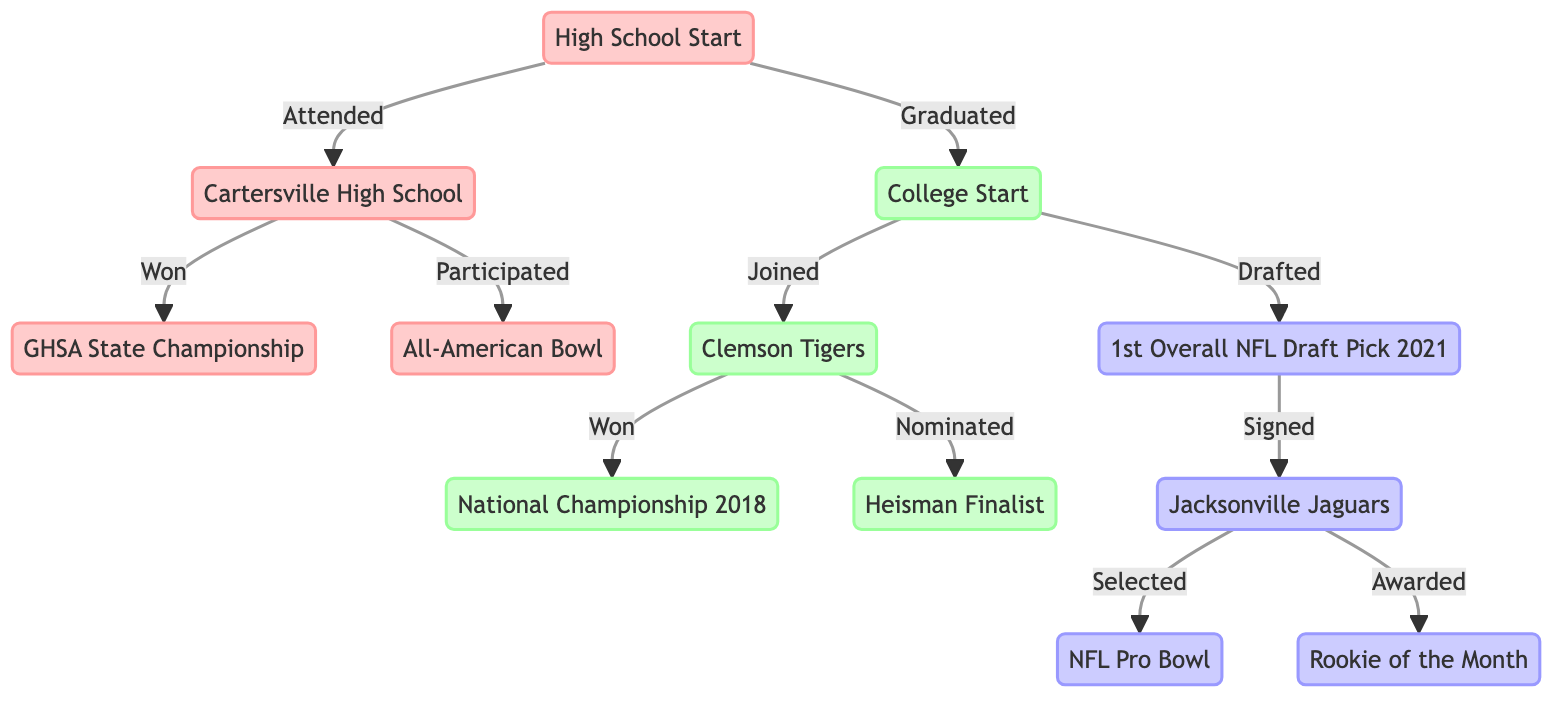What high school did Trevor Lawrence attend? The diagram shows that Trevor Lawrence attended "Cartersville High School" under the "High School" group. This is connected to the node labeled "High School Start" with the relationship labeled "Attended."
Answer: Cartersville High School Which championship did he win in high school? The diagram indicates that while at Cartersville High School, he "Won" the "GHSA State Championship" node, connected directly from Cartersville High.
Answer: GHSA State Championship What college team did Trevor Lawrence join? According to the diagram, Trevor Lawrence joined the "Clemson Tigers" after completing his high school education, as denoted by the relationship labeled "Joined."
Answer: Clemson Tigers How many nodes are there in the professional section? The professional section contains three nodes: "1st Overall NFL Draft Pick 2021," "Jacksonville Jaguars," and "NFL Pro Bowl." This can be counted directly from the diagram.
Answer: 3 What award was Trevor Lawrence awarded during his rookie year? The "Jacksonville Jaguars" node connects to the "Rookie of the Month" with the relation "Awarded," indicating this was the specific award given to him.
Answer: Rookie of the Month What milestone marks the transition from college to professional? The diagram indicates that the milestone representing this transition is "Drafted," connected from "College Start" to "1st Overall NFL Draft Pick 2021."
Answer: Drafted Who was nominated for the Heisman Trophy? From the diagram, the "Nominated" relationship points to "Heisman Finalist" from the "Clemson Tigers" node, demonstrating that it was Trevor Lawrence while he was at Clemson.
Answer: Trevor Lawrence Which milestone occurs after winning the National Championship? The diagram shows that after the "Won" connection from "Clemson Tigers" to "National Championship 2018," the next key milestone is the drafting process leading to the "1st Overall NFL Draft Pick 2021." This helps identify the logical sequence.
Answer: Drafted What team did Trevor Lawrence sign with after being the first overall pick? The relationship shows that he was "Signed" with the "Jacksonville Jaguars" immediately following the milestone "1st Overall NFL Draft Pick 2021." This linkage provides clear information about his professional team.
Answer: Jacksonville Jaguars 